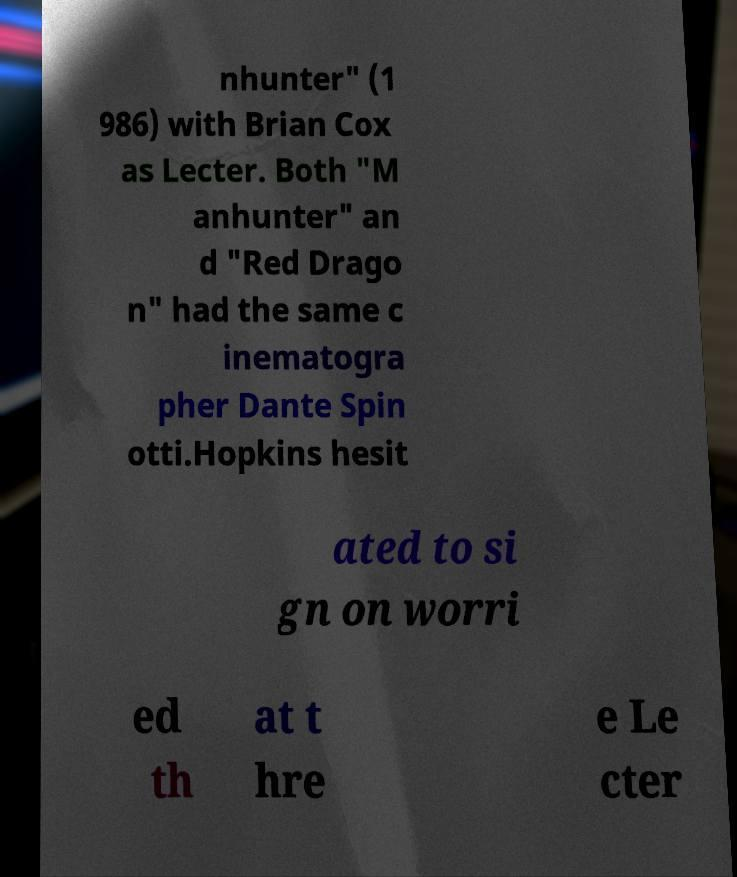Can you accurately transcribe the text from the provided image for me? nhunter" (1 986) with Brian Cox as Lecter. Both "M anhunter" an d "Red Drago n" had the same c inematogra pher Dante Spin otti.Hopkins hesit ated to si gn on worri ed th at t hre e Le cter 